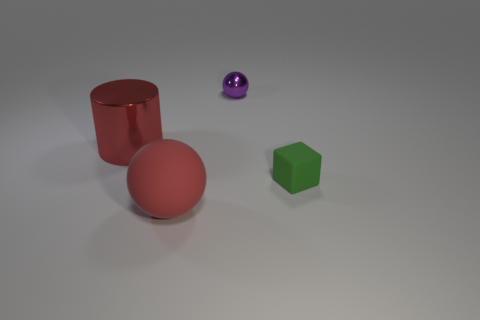Add 3 red matte balls. How many objects exist? 7 Subtract all cylinders. How many objects are left? 3 Subtract 0 red cubes. How many objects are left? 4 Subtract all cyan matte cylinders. Subtract all big red metallic objects. How many objects are left? 3 Add 2 shiny cylinders. How many shiny cylinders are left? 3 Add 3 big red matte balls. How many big red matte balls exist? 4 